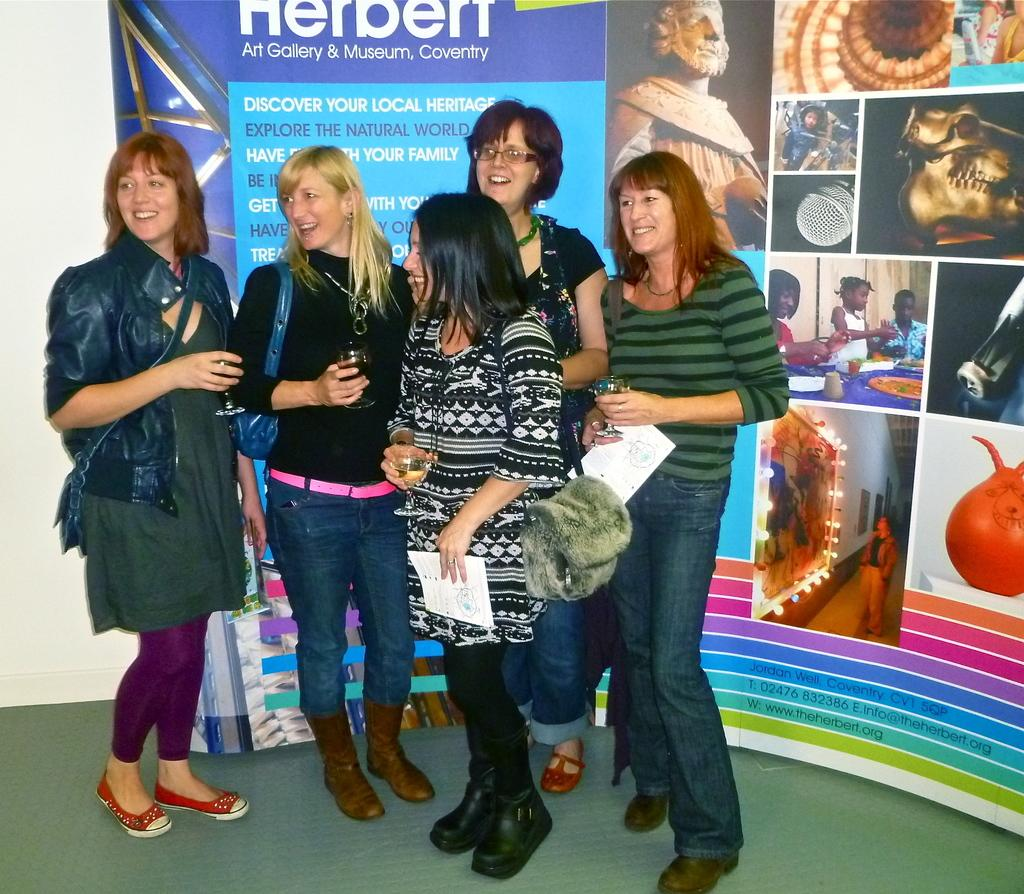How many women are present in the image? There are five women in the image. What is the facial expression of the women? All the women are smiling. Where are the women positioned in the image? The women are standing on the floor. What can be seen in the background of the image? There is a poster and a wall visible in the background. What type of juice is being served from the hole in the image? There is no juice or hole present in the image. 